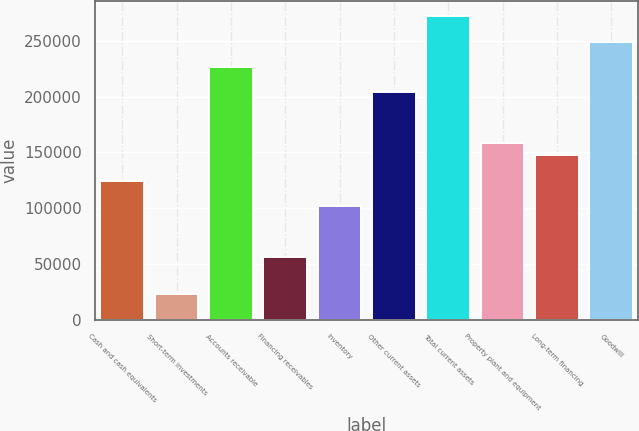Convert chart. <chart><loc_0><loc_0><loc_500><loc_500><bar_chart><fcel>Cash and cash equivalents<fcel>Short-term investments<fcel>Accounts receivable<fcel>Financing receivables<fcel>Inventory<fcel>Other current assets<fcel>Total current assets<fcel>Property plant and equipment<fcel>Long-term financing<fcel>Goodwill<nl><fcel>124662<fcel>22685.4<fcel>226638<fcel>56677.5<fcel>102000<fcel>203977<fcel>271961<fcel>158654<fcel>147323<fcel>249299<nl></chart> 